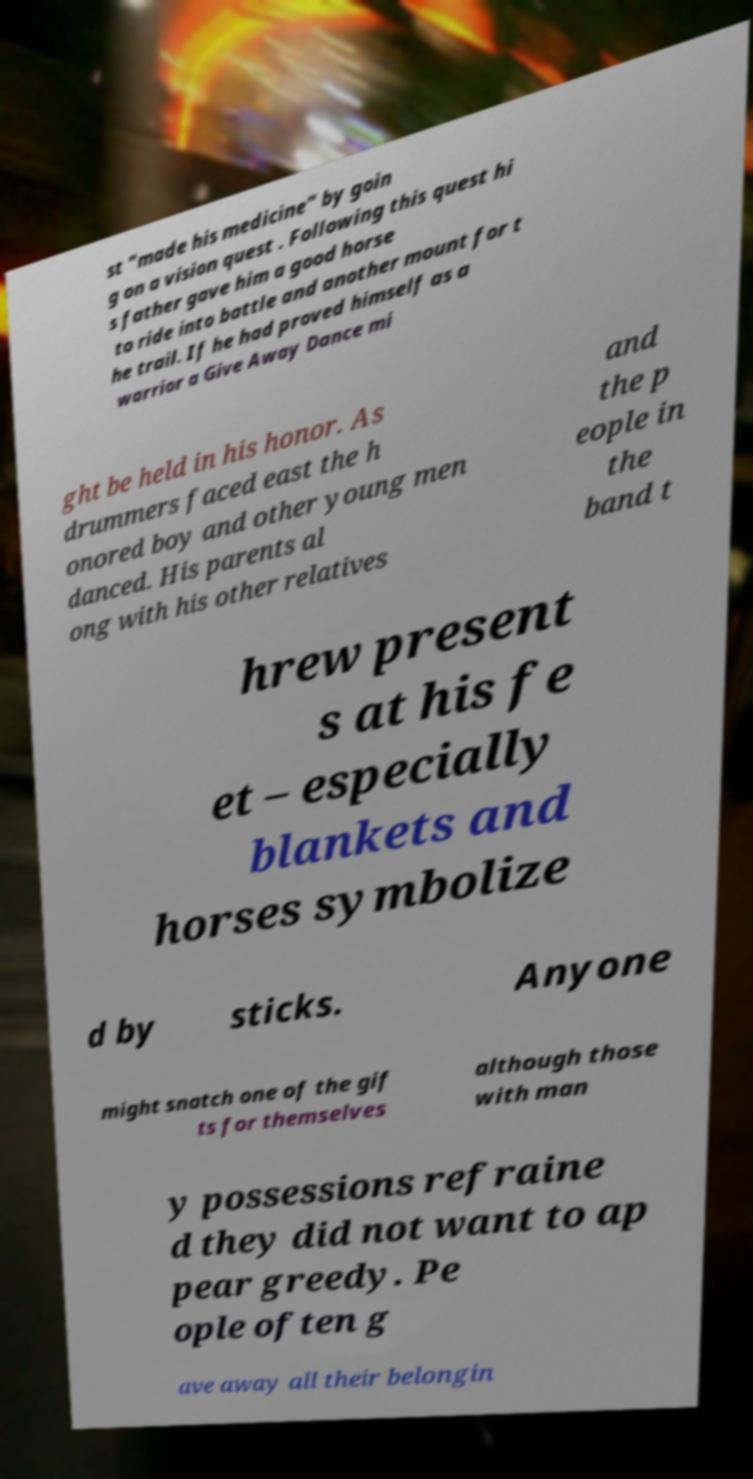There's text embedded in this image that I need extracted. Can you transcribe it verbatim? st "made his medicine" by goin g on a vision quest . Following this quest hi s father gave him a good horse to ride into battle and another mount for t he trail. If he had proved himself as a warrior a Give Away Dance mi ght be held in his honor. As drummers faced east the h onored boy and other young men danced. His parents al ong with his other relatives and the p eople in the band t hrew present s at his fe et – especially blankets and horses symbolize d by sticks. Anyone might snatch one of the gif ts for themselves although those with man y possessions refraine d they did not want to ap pear greedy. Pe ople often g ave away all their belongin 